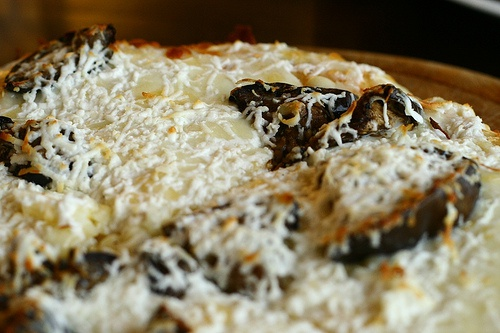Describe the objects in this image and their specific colors. I can see a pizza in darkgray, maroon, tan, lightgray, and beige tones in this image. 